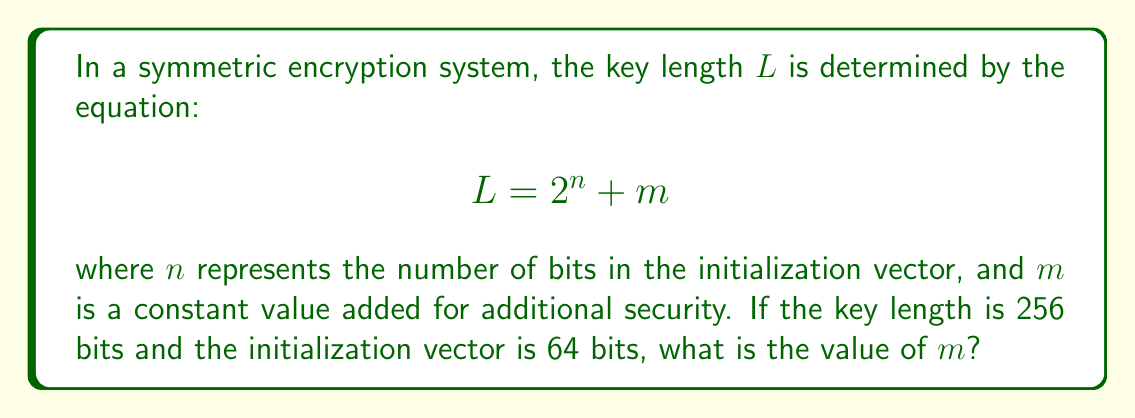Help me with this question. To solve this problem, we'll follow these steps:

1. Identify the given information:
   - Key length $L = 256$ bits
   - Initialization vector length $n = 64$ bits
   - The equation: $L = 2^n + m$

2. Substitute the known values into the equation:
   $$256 = 2^{64} + m$$

3. Calculate $2^{64}$:
   $$2^{64} = 18,446,744,073,709,551,616$$

4. Subtract $2^{64}$ from both sides of the equation:
   $$256 - 18,446,744,073,709,551,616 = m$$

5. Simplify:
   $$m = 256 - 18,446,744,073,709,551,616 = -18,446,744,073,709,551,360$$

The negative value of $m$ indicates that the given equation cannot be satisfied with the provided parameters. In practice, encryption key lengths are typically powers of 2, and the initialization vector length would be smaller than the key length.
Answer: The equation cannot be satisfied with the given parameters. If it were possible, $m$ would equal $-18,446,744,073,709,551,360$. 